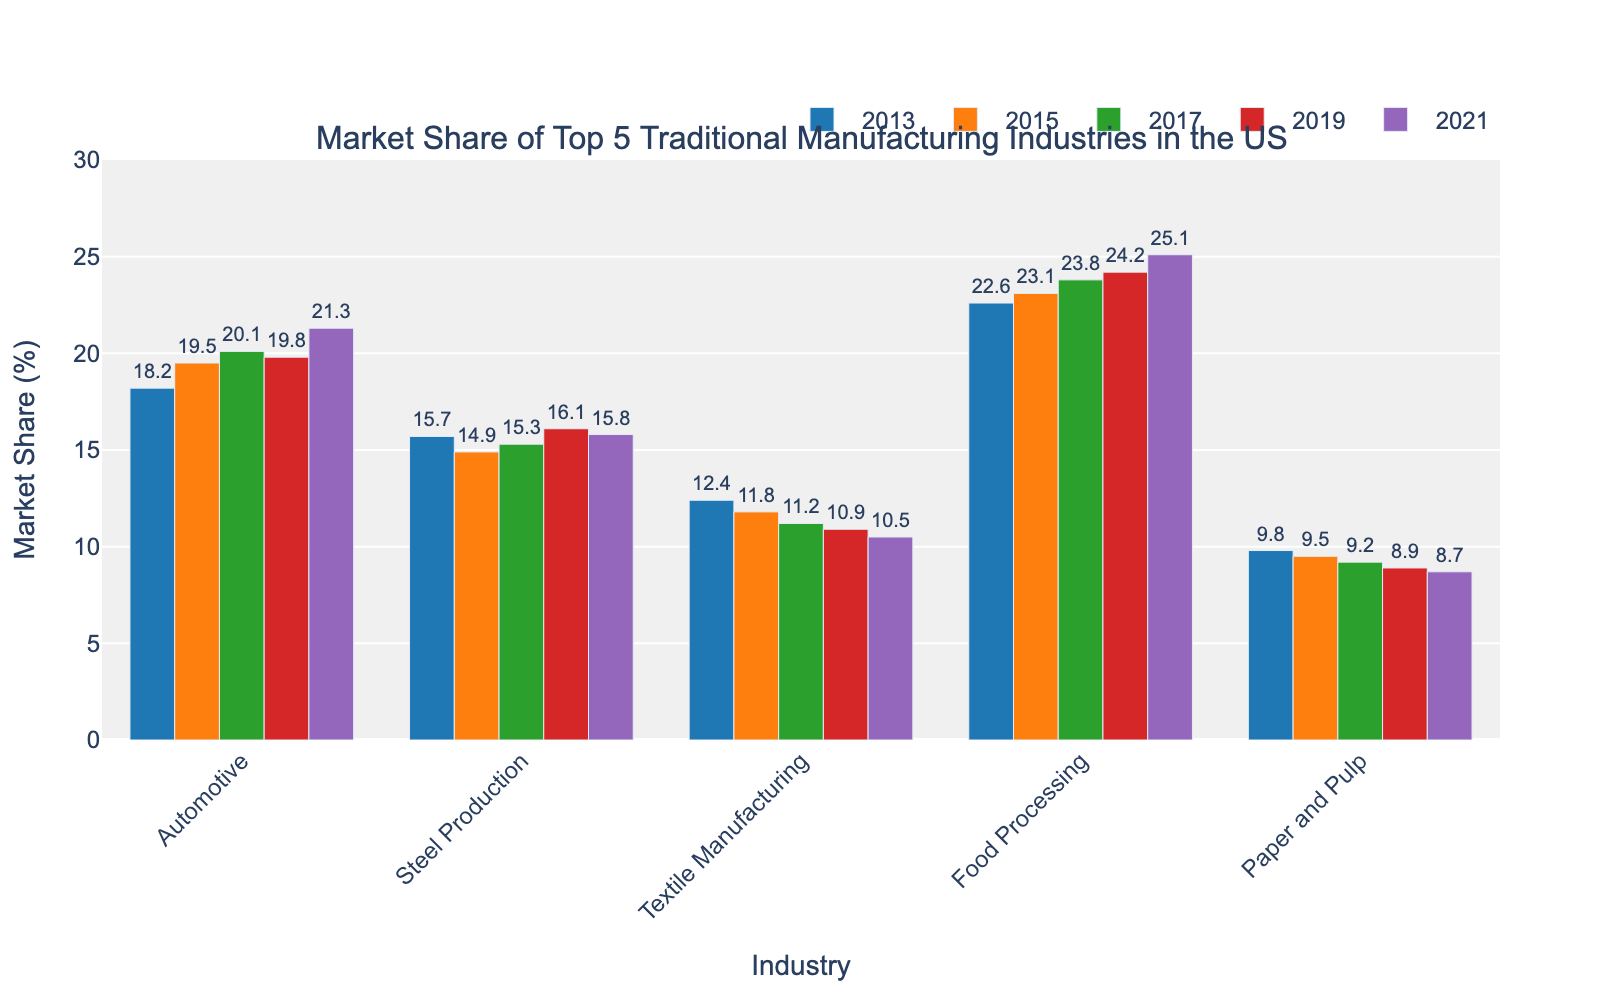Which industry has the highest market share in 2021? To find the industry with the highest market share in 2021, look at the bars for 2021 and identify the tallest one. Food Processing has the highest bar.
Answer: Food Processing Which industry saw the largest increase in market share from 2013 to 2021? To find the industry with the largest increase, subtract the 2013 value from the 2021 value for each industry and compare the differences. Food Processing increased from 22.6 to 25.1 (2.5 percentage points).
Answer: Food Processing How did the market share of Steel Production change over the years? Look at Steel Production across all the years: 2013 (15.7), 2015 (14.9), 2017 (15.3), 2019 (16.1), 2021 (15.8). It decreased from 2013 to 2015, increased into 2019, and slightly decreased again in 2021.
Answer: Decreased, then fluctuated What is the average market share of the Automotive industry over the given years? Find the average by summing the market shares for Automotive and dividing by the number of years: (18.2 + 19.5 + 20.1 + 19.8 + 21.3) / 5 = 19.78.
Answer: 19.78 Which industry consistently had the lowest market share? Identify the industry with the lowest bars across all years. Paper and Pulp has the lowest values: 2013 (9.8), 2015 (9.5), 2017 (9.2), 2019 (8.9), 2021 (8.7).
Answer: Paper and Pulp Compare the market share of Textile Manufacturing in 2013 with 2021. What is the difference? Subtract the market share of Textile Manufacturing in 2013 from 2021: 2013 (12.4) and 2021 (10.5). So, 12.4 - 10.5 = 1.9.
Answer: 1.9 Which year had the smallest difference between the market shares of Automotive and Steel Production? Calculate the absolute differences for each year and compare them: 2013 (18.2 - 15.7 = 2.5), 2015 (19.5 - 14.9 = 4.6), 2017 (20.1 - 15.3 = 4.8), 2019 (19.8 - 16.1 = 3.7), 2021 (21.3 - 15.8 = 5.5). The smallest difference is in 2013.
Answer: 2013 Which industry showed a continuous decline in market share from 2013 to 2021? Look for the industry whose bars decrease every year: Textile Manufacturing from 2013 (12.4) to 2021 (10.5) shows continuous decline.
Answer: Textile Manufacturing 